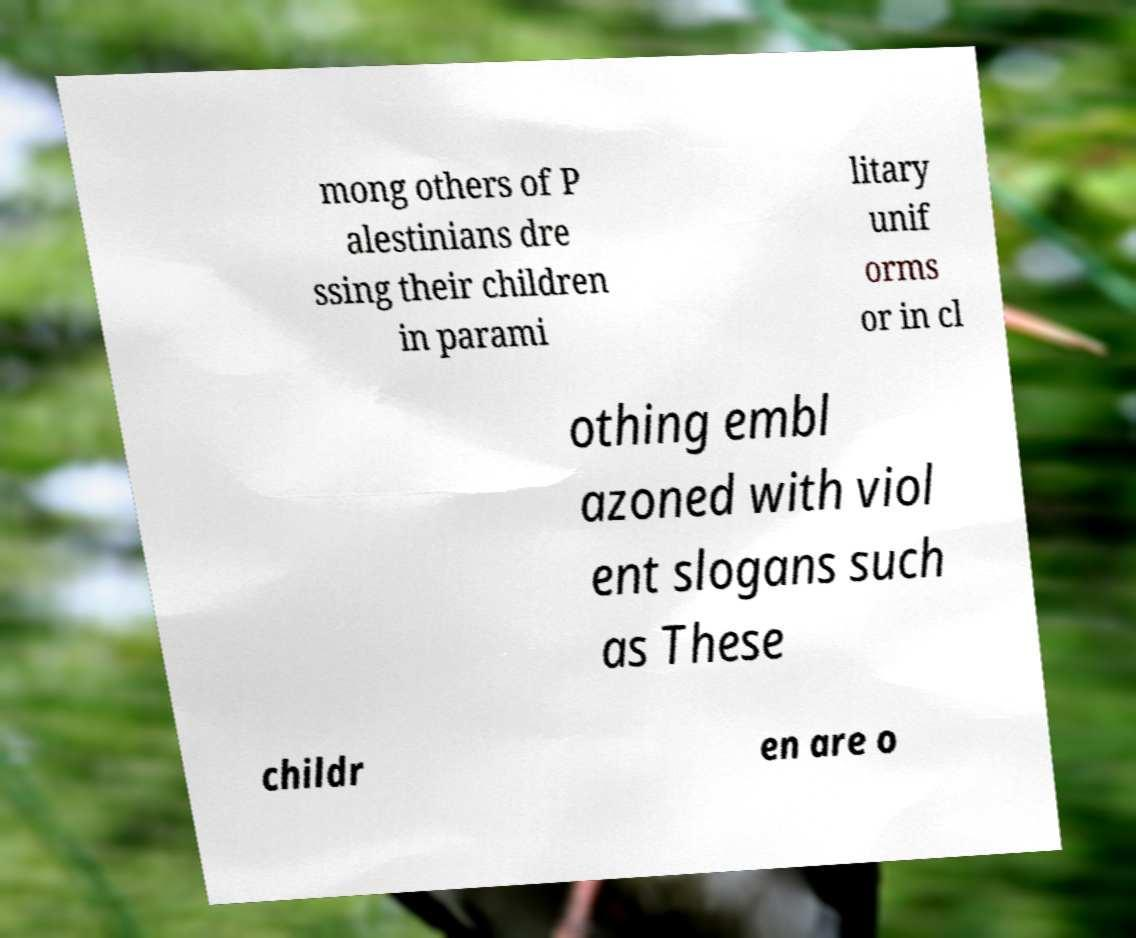Please read and relay the text visible in this image. What does it say? mong others of P alestinians dre ssing their children in parami litary unif orms or in cl othing embl azoned with viol ent slogans such as These childr en are o 